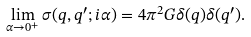<formula> <loc_0><loc_0><loc_500><loc_500>\lim _ { \alpha \rightarrow 0 ^ { + } } \sigma ( q , q ^ { \prime } ; i \alpha ) = 4 \pi ^ { 2 } G \delta ( q ) \delta ( q ^ { \prime } ) .</formula> 